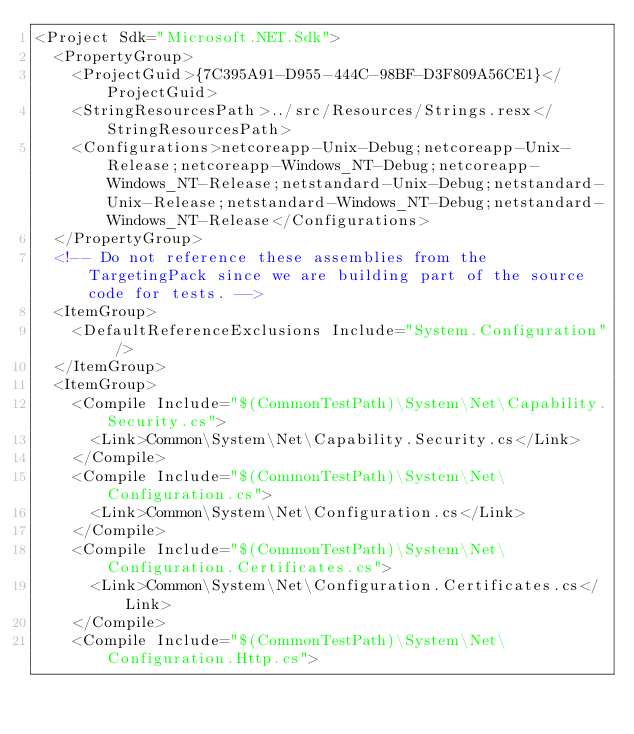<code> <loc_0><loc_0><loc_500><loc_500><_XML_><Project Sdk="Microsoft.NET.Sdk">
  <PropertyGroup>
    <ProjectGuid>{7C395A91-D955-444C-98BF-D3F809A56CE1}</ProjectGuid>
    <StringResourcesPath>../src/Resources/Strings.resx</StringResourcesPath>
    <Configurations>netcoreapp-Unix-Debug;netcoreapp-Unix-Release;netcoreapp-Windows_NT-Debug;netcoreapp-Windows_NT-Release;netstandard-Unix-Debug;netstandard-Unix-Release;netstandard-Windows_NT-Debug;netstandard-Windows_NT-Release</Configurations>
  </PropertyGroup>
  <!-- Do not reference these assemblies from the TargetingPack since we are building part of the source code for tests. -->
  <ItemGroup>
    <DefaultReferenceExclusions Include="System.Configuration" />
  </ItemGroup>
  <ItemGroup>
    <Compile Include="$(CommonTestPath)\System\Net\Capability.Security.cs">
      <Link>Common\System\Net\Capability.Security.cs</Link>
    </Compile>
    <Compile Include="$(CommonTestPath)\System\Net\Configuration.cs">
      <Link>Common\System\Net\Configuration.cs</Link>
    </Compile>
    <Compile Include="$(CommonTestPath)\System\Net\Configuration.Certificates.cs">
      <Link>Common\System\Net\Configuration.Certificates.cs</Link>
    </Compile>
    <Compile Include="$(CommonTestPath)\System\Net\Configuration.Http.cs"></code> 